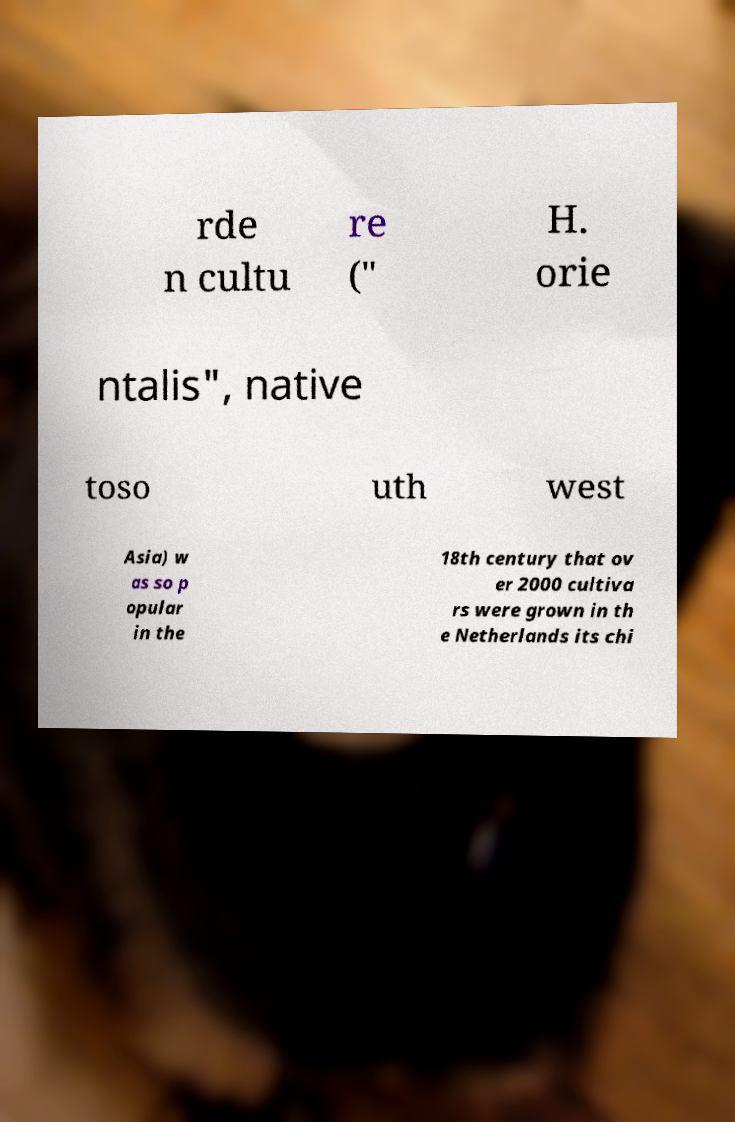Could you extract and type out the text from this image? rde n cultu re (" H. orie ntalis", native toso uth west Asia) w as so p opular in the 18th century that ov er 2000 cultiva rs were grown in th e Netherlands its chi 